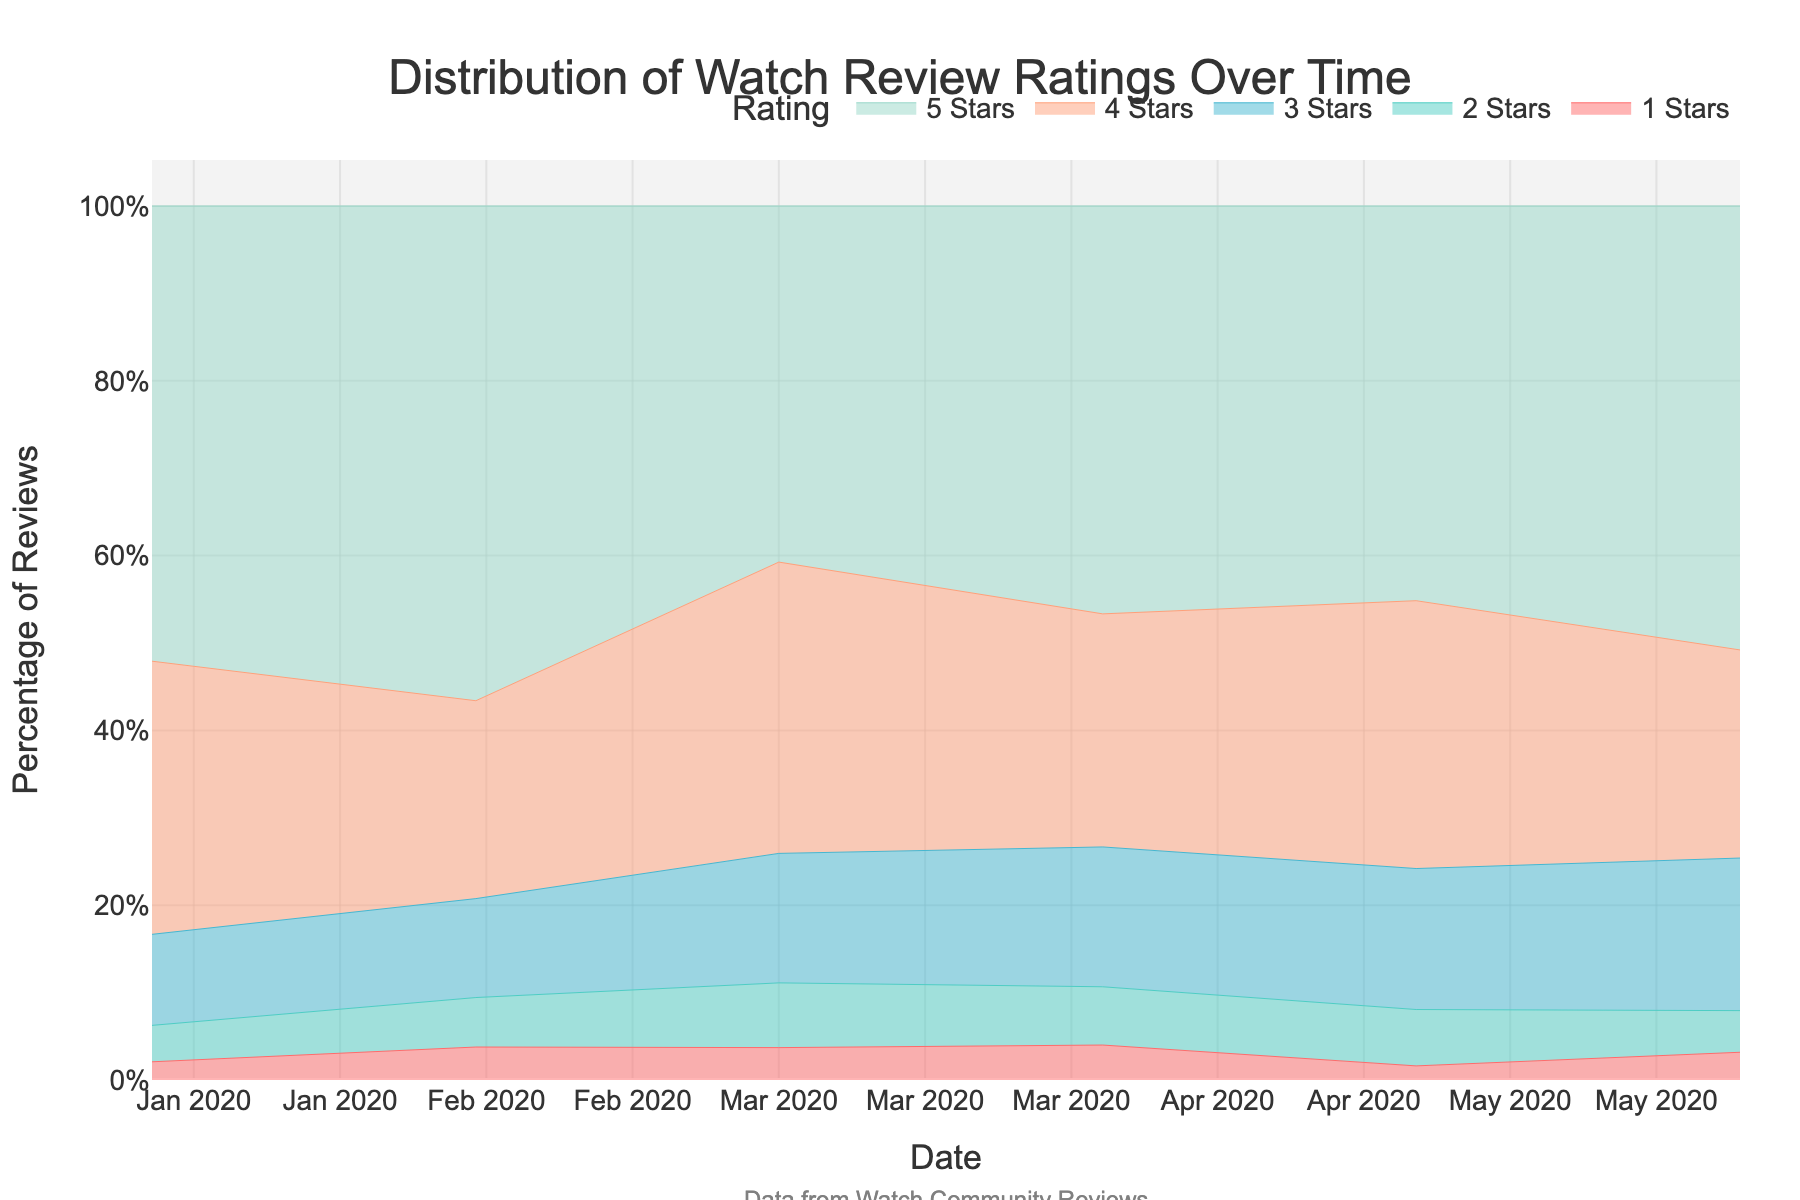What is the title of the figure? The title of the figure is displayed at the top center of the chart and reads 'Distribution of Watch Review Ratings Over Time.'
Answer: Distribution of Watch Review Ratings Over Time What do the x-axis and y-axis represent in the figure? The x-axis represents the date (time) and the y-axis represents the percentage of watch review ratings.
Answer: Date (X-axis) and Percentage of Reviews (Y-axis) Which rating has the highest count in May 2020? To determine this, we look at the area chart for May 2020, where the largest area represents the highest count. For May 2020, the 5-star rating area is the largest.
Answer: 5 Stars How does the percentage of 2-star reviews change from January 2020 to June 2020? From January 2020 to June 2020, the percentage of 2-star reviews remains fairly low and does not show a significant change over time.
Answer: Remains low, no significant change What's the trend for 5-star reviews over the given period? By observing the area representing 5-star reviews, it increases initially, decreases slightly in March, then increases again, suggesting a general upward trend.
Answer: General upward trend Are there any months where 3-star reviews have the same percentage as 4-star reviews? By comparing the areas for 3-star and 4-star reviews month by month, we see they do not have the same percentage in any month, though their changes may be similar.
Answer: No How many different star ratings are represented in this figure? The figure includes areas for 1-star, 2-star, 3-star, 4-star, and 5-star reviews, giving us five different star ratings.
Answer: Five Which rating experiences the most fluctuation over the time period? By examining the fluctuations in the area sizes, the 3-star rating shows a lot of fluctuation in its area percentage over time.
Answer: 3 Stars What is the percentage change of 4-star reviews from February to April 2020? Calculate the difference in the percentage of the 4-star reviews between these two months: April shows an increase in the area percentage of 4-star reviews compared to February.
Answer: Increase What is the proportion of 5-star reviews compared to 4-star reviews in April 2020? By comparing the sizes of the areas, the 5-star reviews area is significantly larger than the 4-star reviews area in April 2020.
Answer: 5-star reviews are larger in proportion 